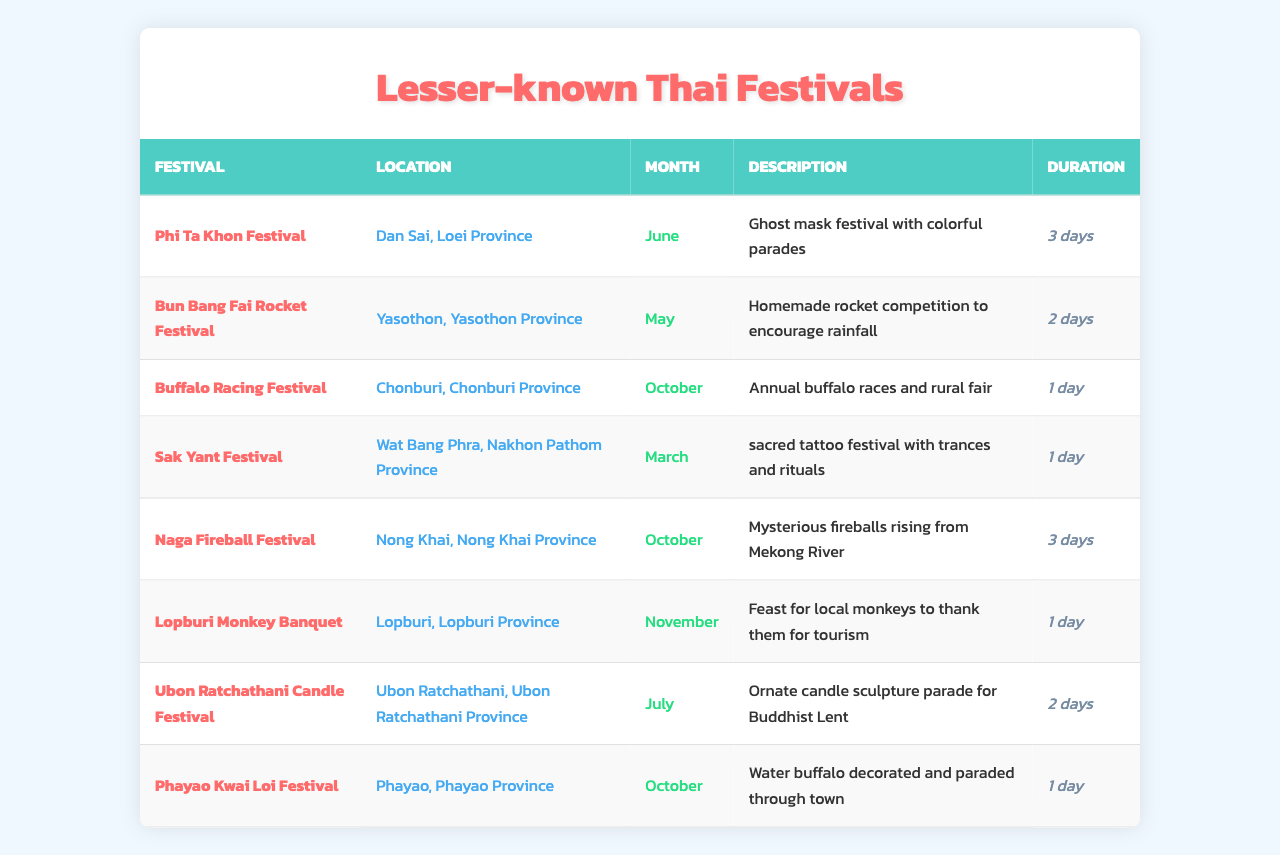What is the duration of the Phi Ta Khon Festival? The Phi Ta Khon Festival has a duration of 3 days, as indicated in the "Duration" column of the table.
Answer: 3 days Where is the Naga Fireball Festival held? The Naga Fireball Festival is located in Nong Khai Province, as stated in the "Location" column.
Answer: Nong Khai Province Does the Buffalo Racing Festival take place in November? According to the table, the Buffalo Racing Festival occurs in October, not November. Therefore, the statement is false.
Answer: False Which festival occurs in July and how long does it last? The Ubon Ratchathani Candle Festival occurs in July and lasts for 2 days, according to the "Month" and "Duration" columns.
Answer: Ubon Ratchathani Candle Festival, 2 days How many festivals have a duration of 1 day? By counting the entries in the "Duration" column, there are 4 festivals that last for 1 day.
Answer: 4 What is the least common month represented in the table? By looking at the "Month" column, March is the least common month with only one festival, the Sak Yant Festival.
Answer: March Calculate the total duration of all festivals that occur in October. The Buffalo Racing Festival lasts 1 day, the Naga Fireball Festival lasts 3 days, and the Phayao Kwai Loi Festival lasts 1 day, making the total duration 1 + 3 + 1 = 5 days.
Answer: 5 days Is the Bun Bang Fai Rocket Festival the only festival in May? Checking the table, the Bun Bang Fai Rocket Festival is the only festival listed for May, confirming the statement to be true.
Answer: True List all the provinces where festivals take place in the table. The table mentions festivals in Loei, Yasothon, Chonburi, Nakhon Pathom, Nong Khai, Lopburi, and Ubon Ratchathani provinces.
Answer: Loei, Yasothon, Chonburi, Nakhon Pathom, Nong Khai, Lopburi, Ubon Ratchathani Which festival has the longest duration and where is it held? The Naga Fireball Festival lasts for 3 days, which is the longest duration, and it is held in Nong Khai.
Answer: Naga Fireball Festival, Nong Khai 